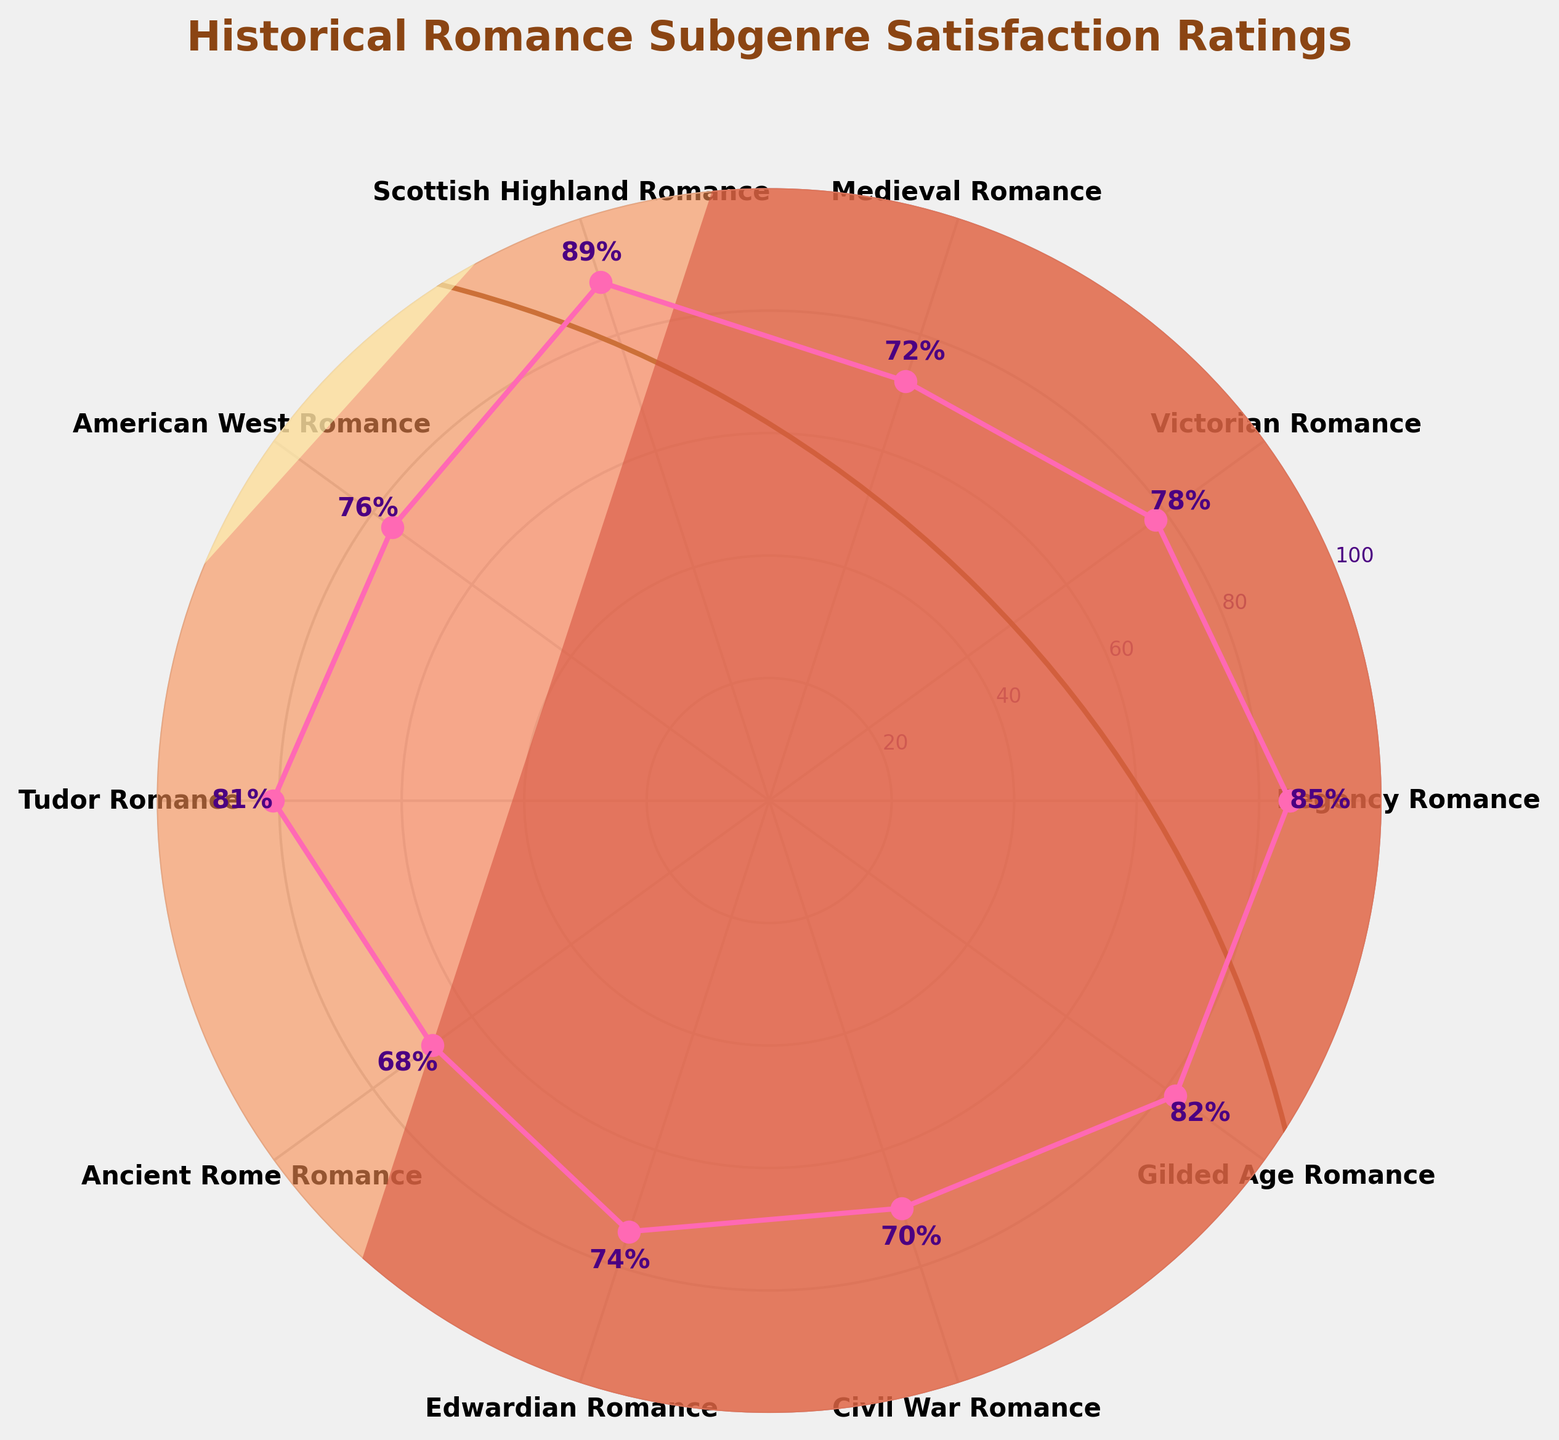What is the satisfaction rating for the Regency Romance subgenre? The Regency Romance subgenre's rating is marked by a point on the chart and also labeled with its exact percentage.
Answer: 85 Which historical romance subgenre has the highest satisfaction rating? By examining the points on the chart and their corresponding labels, the Scottish Highland Romance subgenre has the highest satisfaction rating.
Answer: Scottish Highland Romance How many subgenres have a satisfaction rating above 80%? Counting the subgenres with satisfaction ratings above the 80% mark, there are four: Regency Romance, Scottish Highland Romance, Tudor Romance, and Gilded Age Romance.
Answer: 4 Which subgenre has a lower rating: Victorian Romance or Edwardian Romance? By comparing the points and their labels on the chart, the Victorian Romance has a satisfaction rating of 78, while the Edwardian Romance has a rating of 74. Therefore, Edwardian Romance has a lower rating.
Answer: Edwardian Romance What is the average satisfaction rating of all the listed subgenres? Add all the satisfaction ratings together: 85 + 78 + 72 + 89 + 76 + 81 + 68 + 74 + 70 + 82 = 775. Then divide by the number of subgenres, which is 10. The average rating is 775/10 = 77.5.
Answer: 77.5 Which subgenre has a rating closest to the average satisfaction rating? The average satisfaction rating is 77.5. Comparing the ratings to 77.5, the closest ratings are Victorian Romance (78) and American West Romance (76). Victorian Romance is closer.
Answer: Victorian Romance What is the difference in satisfaction ratings between the highest and lowest-rated subgenres? The highest rating is 89 (Scottish Highland Romance) and the lowest is 68 (Ancient Rome Romance). The difference is 89 - 68 = 21.
Answer: 21 What percentage of the subgenres have satisfaction ratings below 75%? First, count the number of subgenres with ratings below 75% (Medieval Romance, American West Romance, Ancient Rome Romance, Edwardian Romance, Civil War Romance), which is 5 out of 10. So, 5 out of 10 is 50%.
Answer: 50% Is the satisfaction rating for Ancient Rome Romance higher or lower than the median satisfaction rating of all subgenres? To find the median, sort the ratings: 68, 70, 72, 74, 76, 78, 81, 82, 85, 89. The median is the average of the 5th and 6th values: (76+78)/2 = 77. Ancient Rome Romance has a rating of 68, which is lower than 77.
Answer: Lower 